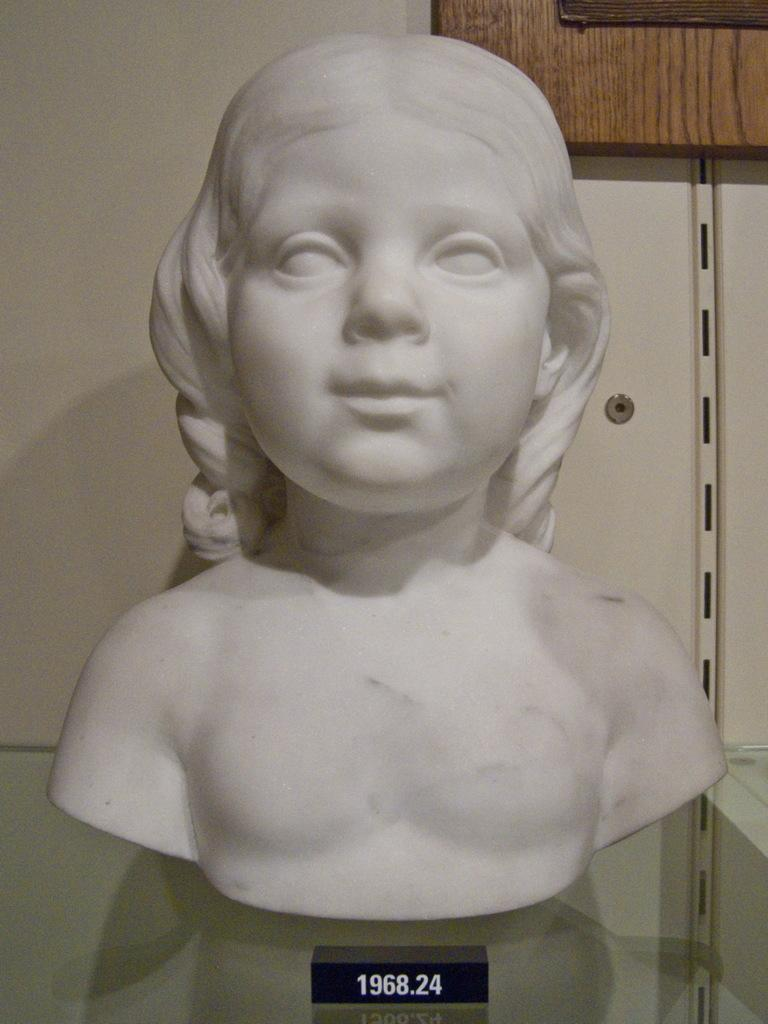What is the main subject in the image? There is a sculpture in the image. Where is the sculpture located in relation to the image? The sculpture is in the front of the image. What is visible at the bottom of the image? There is glass at the bottom of the image. What can be seen in the background of the image? There is a wall in the background of the image. What type of lunch is being served on the donkey in the image? There is no donkey or lunch present in the image; it features a sculpture and a wall in the background. 